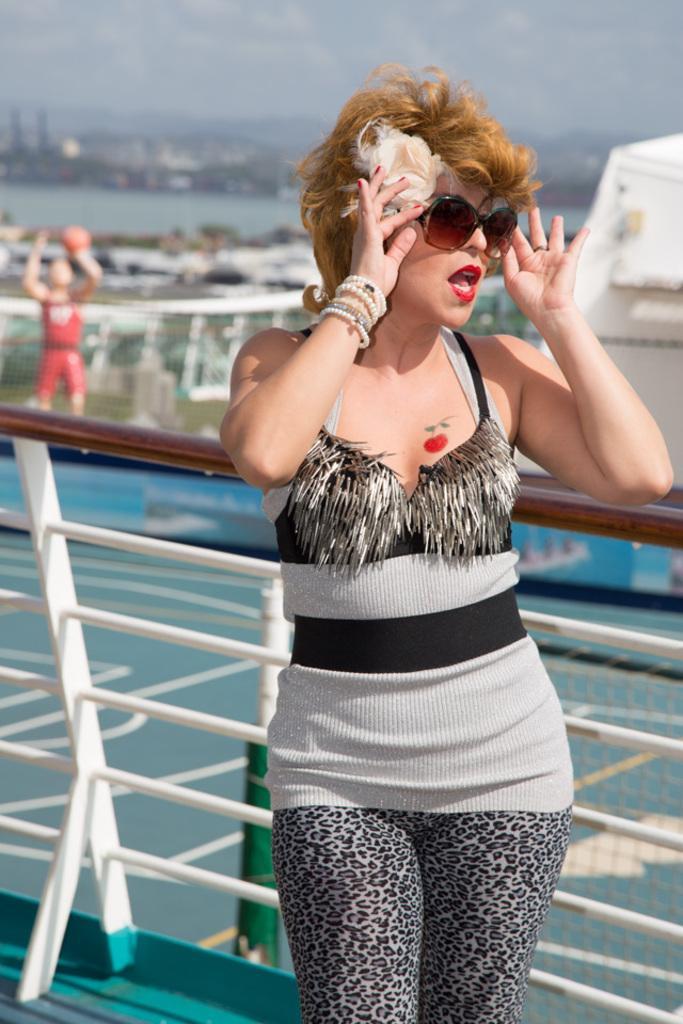How would you summarize this image in a sentence or two? In the picture there is a woman. she is standing inside a ship and posing for the photo. Behind the woman there are many other boats and ships on the water. 